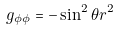Convert formula to latex. <formula><loc_0><loc_0><loc_500><loc_500>g _ { \phi \phi } = - \sin ^ { 2 } { \theta } r ^ { 2 }</formula> 